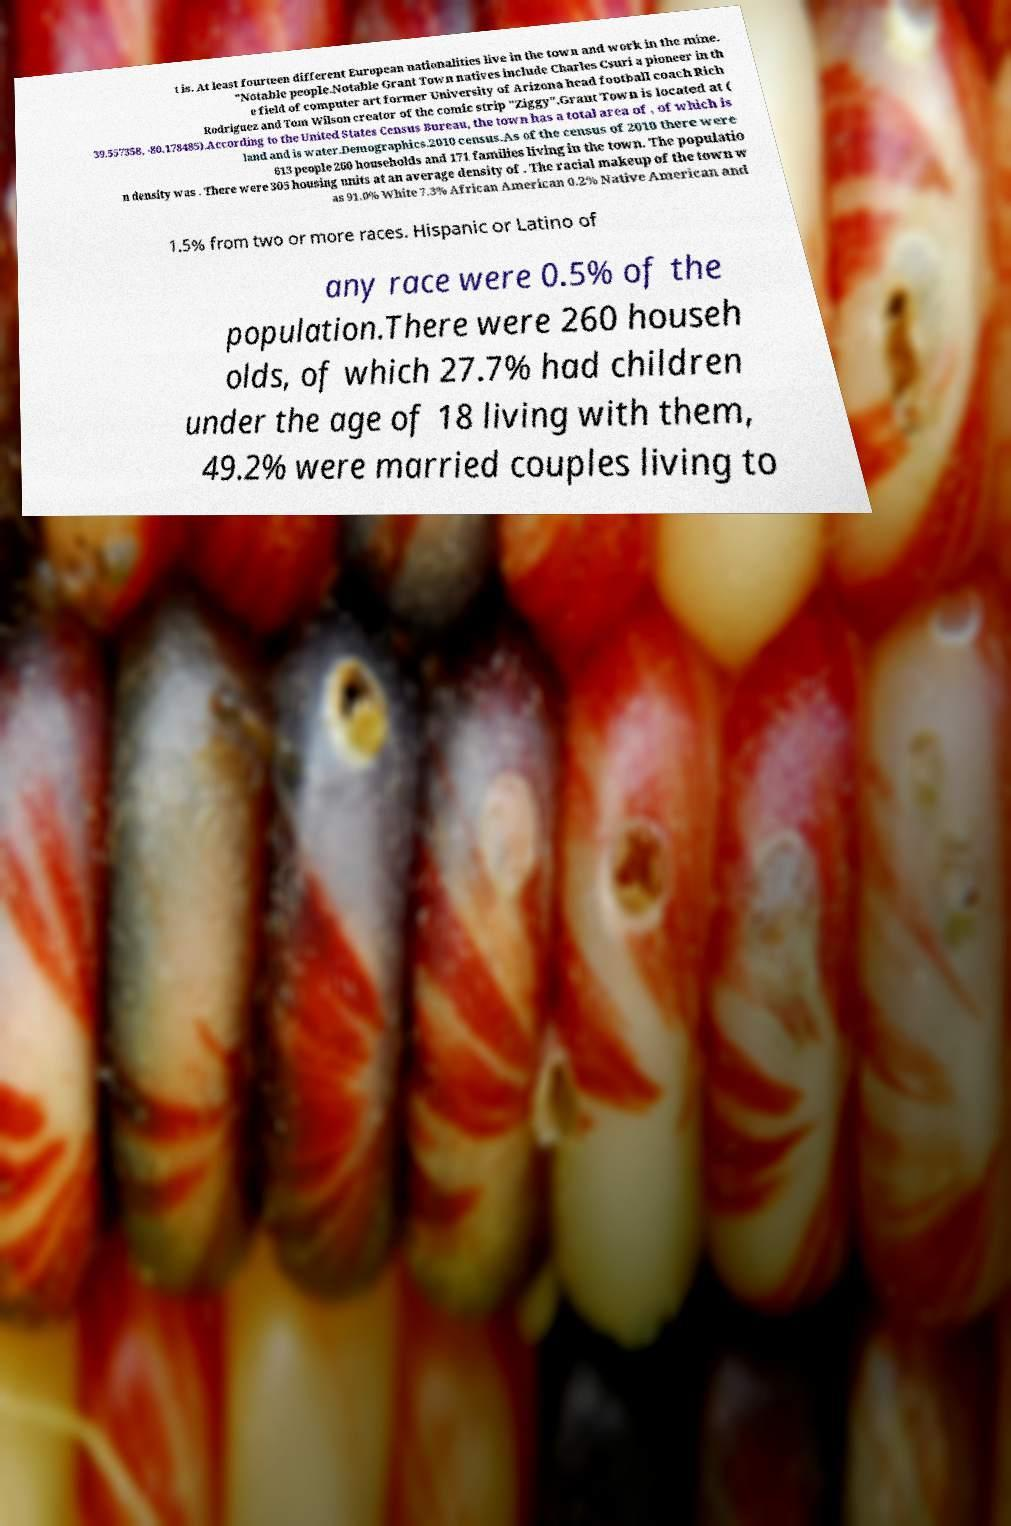Could you assist in decoding the text presented in this image and type it out clearly? t is. At least fourteen different European nationalities live in the town and work in the mine. "Notable people.Notable Grant Town natives include Charles Csuri a pioneer in th e field of computer art former University of Arizona head football coach Rich Rodriguez and Tom Wilson creator of the comic strip "Ziggy".Grant Town is located at ( 39.557358, -80.178485).According to the United States Census Bureau, the town has a total area of , of which is land and is water.Demographics.2010 census.As of the census of 2010 there were 613 people 260 households and 171 families living in the town. The populatio n density was . There were 305 housing units at an average density of . The racial makeup of the town w as 91.0% White 7.3% African American 0.2% Native American and 1.5% from two or more races. Hispanic or Latino of any race were 0.5% of the population.There were 260 househ olds, of which 27.7% had children under the age of 18 living with them, 49.2% were married couples living to 